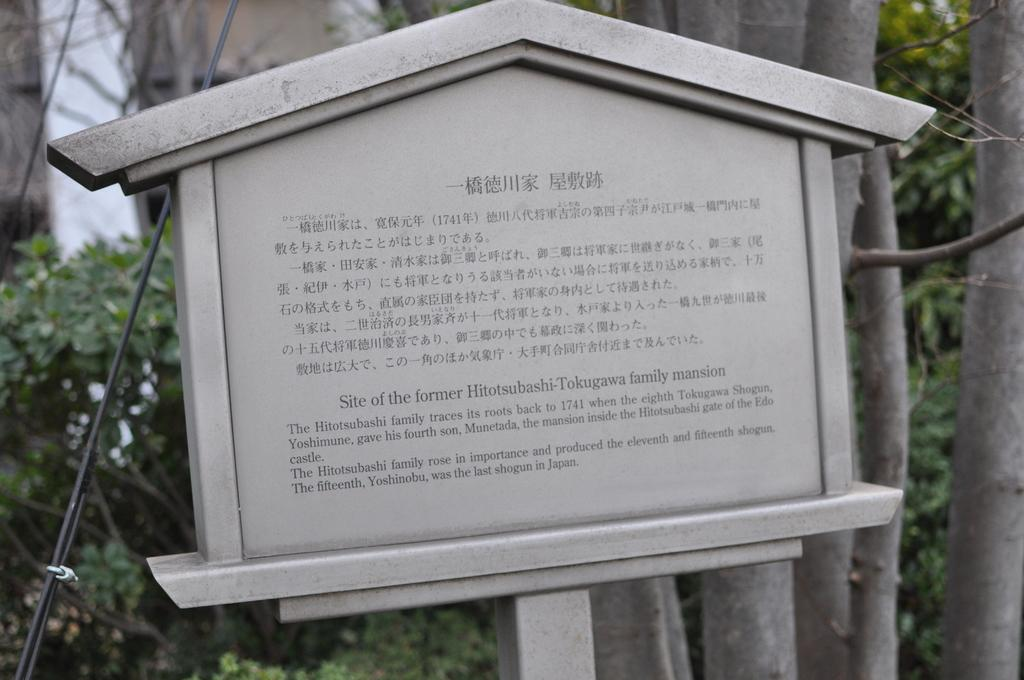What is the main object in the image? There is a sign board in the image. How is the sign board supported? The sign board is placed on a rod. What can be seen in the background of the image? There is a group of trees, wires, and plants visible in the background of the image. What type of frame is used to hold the plants in the image? There is no frame present in the image; the plants are not contained within a frame. 